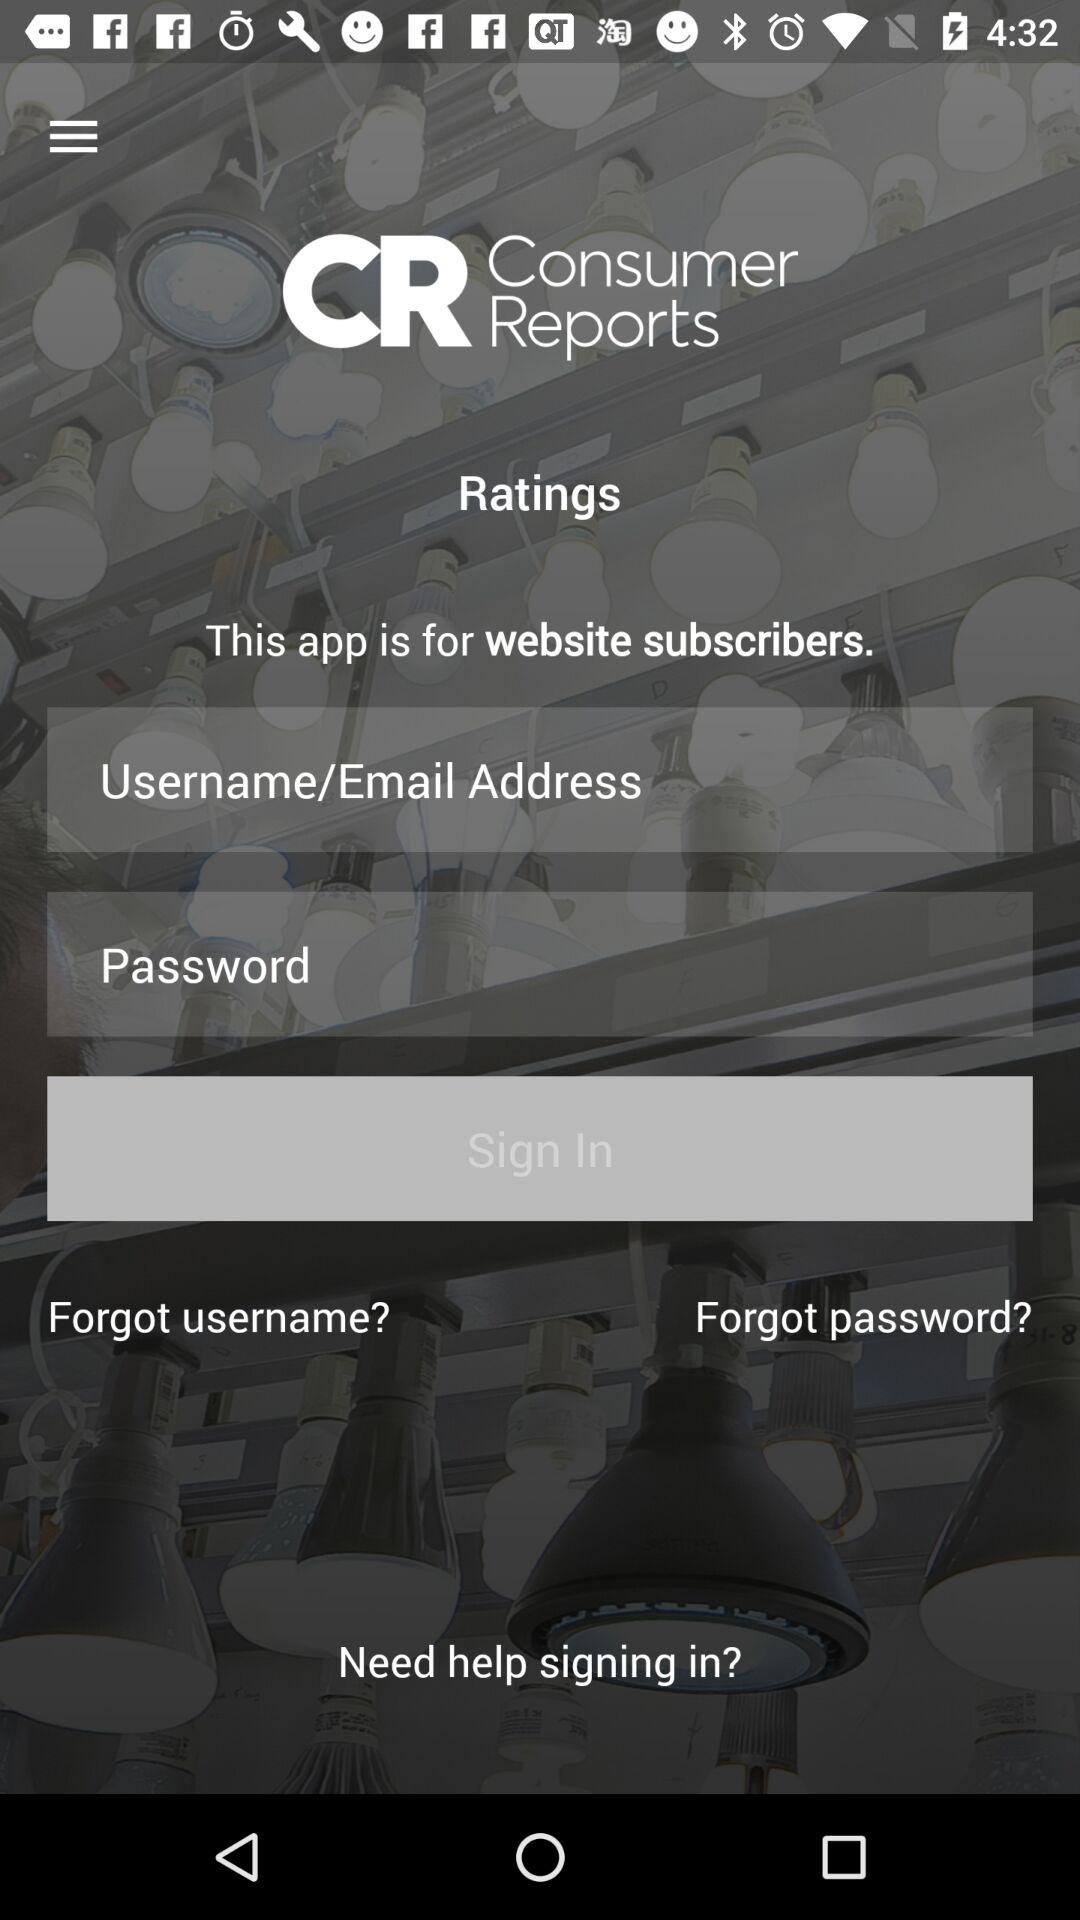What features are available for users who may have forgotten their login credentials? The interface provides two links for users who have forgotten their login credentials: 'Forgot username?' and 'Forgot password?' which likely lead to a process to recover or reset the needed information. 